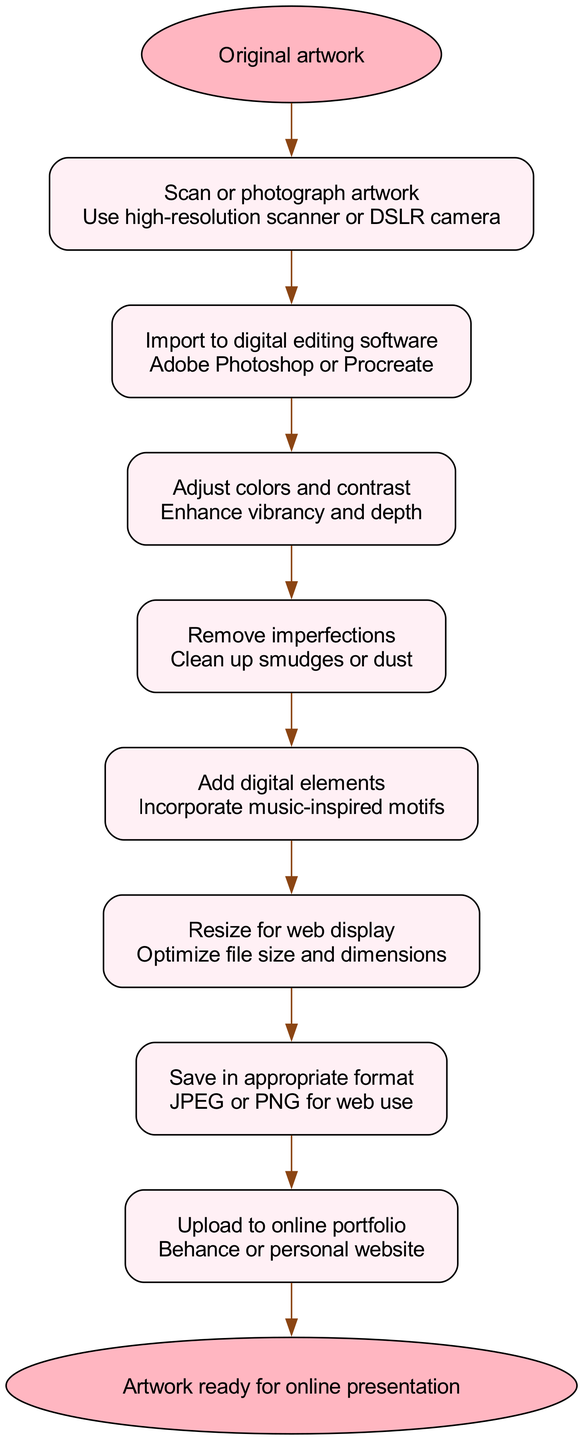What is the first step in the workflow? The first step in the workflow is explicitly labeled as "Scan or photograph artwork." This can be seen as the first node following the "Original artwork" which is the starting point.
Answer: Scan or photograph artwork How many steps are there in total? By counting the steps listed in the diagram, there are eight distinct actions or steps that need to be performed in the workflow before reaching the end.
Answer: 8 What follows after removing imperfections? The flow of the diagram shows that after the step "Remove imperfections," the next action is "Add digital elements." There is a direct connection indicated by an edge between these two nodes.
Answer: Add digital elements Which software can be used for importing the artwork? The diagram mentions "Adobe Photoshop or Procreate" in the step "Import to digital editing software," indicating these are the options available for this action.
Answer: Adobe Photoshop or Procreate What is the last node in the diagram? The diagram culminates at the last node labeled "Artwork ready for online presentation," which clearly signifies the end result of the entire workflow process.
Answer: Artwork ready for online presentation How do you resize the artwork? The diagram specifies the step "Resize for web display," which indicates that resizing is focused on optimizing the file size and dimensions for online display.
Answer: Resize for web display What is the purpose of scanning or photographing the artwork? The initial step, "Scan or photograph artwork," implies that it serves to create a digital representation of the original artwork, utilizing high-resolution tools like a scanner or DSLR camera as stated in its details.
Answer: Create a digital representation What is the main action after adding digital elements? The diagram shows that after "Add digital elements," the next step is "Resize for web display." This indicates the order of actions taken in the workflow sequence.
Answer: Resize for web display 